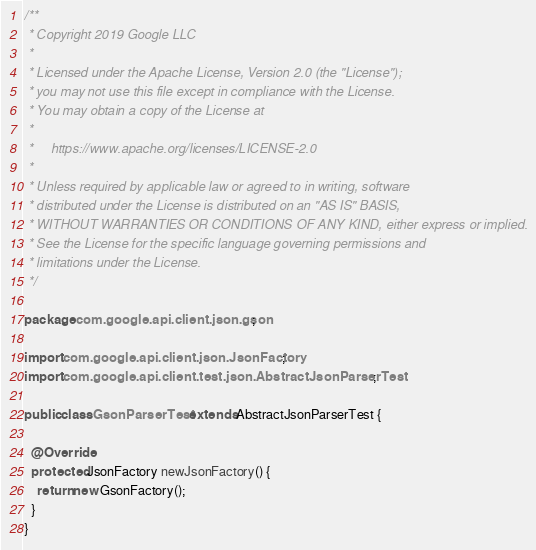<code> <loc_0><loc_0><loc_500><loc_500><_Java_>/**
 * Copyright 2019 Google LLC
 *
 * Licensed under the Apache License, Version 2.0 (the "License");
 * you may not use this file except in compliance with the License.
 * You may obtain a copy of the License at
 *
 *     https://www.apache.org/licenses/LICENSE-2.0
 *
 * Unless required by applicable law or agreed to in writing, software
 * distributed under the License is distributed on an "AS IS" BASIS,
 * WITHOUT WARRANTIES OR CONDITIONS OF ANY KIND, either express or implied.
 * See the License for the specific language governing permissions and
 * limitations under the License.
 */

package com.google.api.client.json.gson;

import com.google.api.client.json.JsonFactory;
import com.google.api.client.test.json.AbstractJsonParserTest;

public class GsonParserTest extends AbstractJsonParserTest {

  @Override
  protected JsonFactory newJsonFactory() {
    return new GsonFactory();
  }
}
</code> 